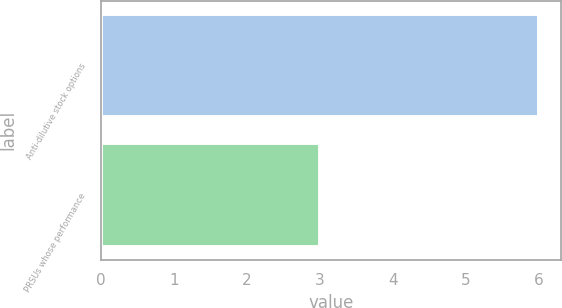Convert chart to OTSL. <chart><loc_0><loc_0><loc_500><loc_500><bar_chart><fcel>Anti-dilutive stock options<fcel>PRSUs whose performance<nl><fcel>6<fcel>3<nl></chart> 